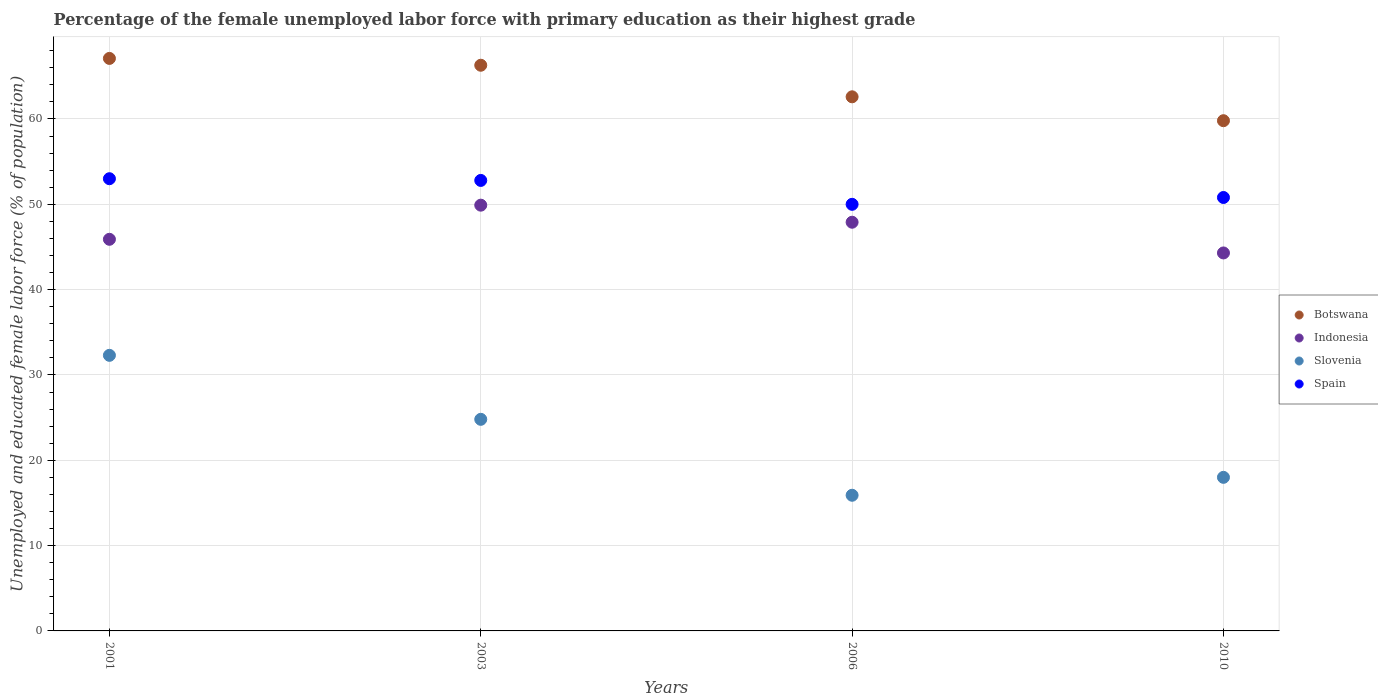Is the number of dotlines equal to the number of legend labels?
Offer a terse response. Yes. What is the percentage of the unemployed female labor force with primary education in Botswana in 2001?
Ensure brevity in your answer.  67.1. Across all years, what is the maximum percentage of the unemployed female labor force with primary education in Slovenia?
Offer a terse response. 32.3. Across all years, what is the minimum percentage of the unemployed female labor force with primary education in Botswana?
Offer a terse response. 59.8. What is the total percentage of the unemployed female labor force with primary education in Slovenia in the graph?
Your response must be concise. 91. What is the difference between the percentage of the unemployed female labor force with primary education in Botswana in 2003 and that in 2010?
Your answer should be compact. 6.5. What is the average percentage of the unemployed female labor force with primary education in Botswana per year?
Your response must be concise. 63.95. In the year 2003, what is the difference between the percentage of the unemployed female labor force with primary education in Spain and percentage of the unemployed female labor force with primary education in Botswana?
Offer a terse response. -13.5. In how many years, is the percentage of the unemployed female labor force with primary education in Spain greater than 50 %?
Offer a very short reply. 3. What is the ratio of the percentage of the unemployed female labor force with primary education in Slovenia in 2006 to that in 2010?
Offer a very short reply. 0.88. Is the percentage of the unemployed female labor force with primary education in Indonesia in 2006 less than that in 2010?
Offer a very short reply. No. Is the difference between the percentage of the unemployed female labor force with primary education in Spain in 2003 and 2010 greater than the difference between the percentage of the unemployed female labor force with primary education in Botswana in 2003 and 2010?
Give a very brief answer. No. What is the difference between the highest and the second highest percentage of the unemployed female labor force with primary education in Slovenia?
Your answer should be very brief. 7.5. What is the difference between the highest and the lowest percentage of the unemployed female labor force with primary education in Indonesia?
Your answer should be compact. 5.6. In how many years, is the percentage of the unemployed female labor force with primary education in Botswana greater than the average percentage of the unemployed female labor force with primary education in Botswana taken over all years?
Make the answer very short. 2. How many dotlines are there?
Offer a terse response. 4. How many years are there in the graph?
Your response must be concise. 4. What is the difference between two consecutive major ticks on the Y-axis?
Your answer should be compact. 10. Are the values on the major ticks of Y-axis written in scientific E-notation?
Provide a succinct answer. No. Where does the legend appear in the graph?
Your response must be concise. Center right. How many legend labels are there?
Ensure brevity in your answer.  4. What is the title of the graph?
Provide a succinct answer. Percentage of the female unemployed labor force with primary education as their highest grade. Does "Cyprus" appear as one of the legend labels in the graph?
Provide a succinct answer. No. What is the label or title of the X-axis?
Make the answer very short. Years. What is the label or title of the Y-axis?
Ensure brevity in your answer.  Unemployed and educated female labor force (% of population). What is the Unemployed and educated female labor force (% of population) of Botswana in 2001?
Ensure brevity in your answer.  67.1. What is the Unemployed and educated female labor force (% of population) in Indonesia in 2001?
Provide a succinct answer. 45.9. What is the Unemployed and educated female labor force (% of population) in Slovenia in 2001?
Give a very brief answer. 32.3. What is the Unemployed and educated female labor force (% of population) of Spain in 2001?
Make the answer very short. 53. What is the Unemployed and educated female labor force (% of population) of Botswana in 2003?
Provide a short and direct response. 66.3. What is the Unemployed and educated female labor force (% of population) in Indonesia in 2003?
Ensure brevity in your answer.  49.9. What is the Unemployed and educated female labor force (% of population) of Slovenia in 2003?
Your answer should be very brief. 24.8. What is the Unemployed and educated female labor force (% of population) in Spain in 2003?
Make the answer very short. 52.8. What is the Unemployed and educated female labor force (% of population) of Botswana in 2006?
Offer a terse response. 62.6. What is the Unemployed and educated female labor force (% of population) in Indonesia in 2006?
Your answer should be compact. 47.9. What is the Unemployed and educated female labor force (% of population) of Slovenia in 2006?
Provide a succinct answer. 15.9. What is the Unemployed and educated female labor force (% of population) in Botswana in 2010?
Offer a very short reply. 59.8. What is the Unemployed and educated female labor force (% of population) of Indonesia in 2010?
Your answer should be compact. 44.3. What is the Unemployed and educated female labor force (% of population) in Spain in 2010?
Provide a short and direct response. 50.8. Across all years, what is the maximum Unemployed and educated female labor force (% of population) in Botswana?
Keep it short and to the point. 67.1. Across all years, what is the maximum Unemployed and educated female labor force (% of population) of Indonesia?
Ensure brevity in your answer.  49.9. Across all years, what is the maximum Unemployed and educated female labor force (% of population) of Slovenia?
Provide a succinct answer. 32.3. Across all years, what is the maximum Unemployed and educated female labor force (% of population) of Spain?
Keep it short and to the point. 53. Across all years, what is the minimum Unemployed and educated female labor force (% of population) in Botswana?
Your answer should be very brief. 59.8. Across all years, what is the minimum Unemployed and educated female labor force (% of population) of Indonesia?
Provide a short and direct response. 44.3. Across all years, what is the minimum Unemployed and educated female labor force (% of population) of Slovenia?
Your answer should be very brief. 15.9. Across all years, what is the minimum Unemployed and educated female labor force (% of population) in Spain?
Ensure brevity in your answer.  50. What is the total Unemployed and educated female labor force (% of population) in Botswana in the graph?
Offer a terse response. 255.8. What is the total Unemployed and educated female labor force (% of population) of Indonesia in the graph?
Ensure brevity in your answer.  188. What is the total Unemployed and educated female labor force (% of population) in Slovenia in the graph?
Offer a terse response. 91. What is the total Unemployed and educated female labor force (% of population) of Spain in the graph?
Provide a short and direct response. 206.6. What is the difference between the Unemployed and educated female labor force (% of population) of Botswana in 2001 and that in 2003?
Give a very brief answer. 0.8. What is the difference between the Unemployed and educated female labor force (% of population) in Slovenia in 2001 and that in 2003?
Your answer should be very brief. 7.5. What is the difference between the Unemployed and educated female labor force (% of population) of Spain in 2001 and that in 2003?
Offer a terse response. 0.2. What is the difference between the Unemployed and educated female labor force (% of population) of Botswana in 2001 and that in 2006?
Offer a very short reply. 4.5. What is the difference between the Unemployed and educated female labor force (% of population) in Indonesia in 2001 and that in 2006?
Provide a succinct answer. -2. What is the difference between the Unemployed and educated female labor force (% of population) in Slovenia in 2001 and that in 2010?
Your response must be concise. 14.3. What is the difference between the Unemployed and educated female labor force (% of population) of Spain in 2001 and that in 2010?
Keep it short and to the point. 2.2. What is the difference between the Unemployed and educated female labor force (% of population) of Indonesia in 2003 and that in 2006?
Ensure brevity in your answer.  2. What is the difference between the Unemployed and educated female labor force (% of population) of Slovenia in 2003 and that in 2006?
Your answer should be very brief. 8.9. What is the difference between the Unemployed and educated female labor force (% of population) in Indonesia in 2003 and that in 2010?
Your answer should be very brief. 5.6. What is the difference between the Unemployed and educated female labor force (% of population) of Slovenia in 2003 and that in 2010?
Provide a succinct answer. 6.8. What is the difference between the Unemployed and educated female labor force (% of population) of Botswana in 2006 and that in 2010?
Ensure brevity in your answer.  2.8. What is the difference between the Unemployed and educated female labor force (% of population) in Slovenia in 2006 and that in 2010?
Offer a terse response. -2.1. What is the difference between the Unemployed and educated female labor force (% of population) in Spain in 2006 and that in 2010?
Your response must be concise. -0.8. What is the difference between the Unemployed and educated female labor force (% of population) of Botswana in 2001 and the Unemployed and educated female labor force (% of population) of Indonesia in 2003?
Ensure brevity in your answer.  17.2. What is the difference between the Unemployed and educated female labor force (% of population) in Botswana in 2001 and the Unemployed and educated female labor force (% of population) in Slovenia in 2003?
Provide a short and direct response. 42.3. What is the difference between the Unemployed and educated female labor force (% of population) of Indonesia in 2001 and the Unemployed and educated female labor force (% of population) of Slovenia in 2003?
Offer a terse response. 21.1. What is the difference between the Unemployed and educated female labor force (% of population) in Indonesia in 2001 and the Unemployed and educated female labor force (% of population) in Spain in 2003?
Your answer should be compact. -6.9. What is the difference between the Unemployed and educated female labor force (% of population) of Slovenia in 2001 and the Unemployed and educated female labor force (% of population) of Spain in 2003?
Your response must be concise. -20.5. What is the difference between the Unemployed and educated female labor force (% of population) of Botswana in 2001 and the Unemployed and educated female labor force (% of population) of Slovenia in 2006?
Provide a short and direct response. 51.2. What is the difference between the Unemployed and educated female labor force (% of population) of Botswana in 2001 and the Unemployed and educated female labor force (% of population) of Spain in 2006?
Give a very brief answer. 17.1. What is the difference between the Unemployed and educated female labor force (% of population) of Indonesia in 2001 and the Unemployed and educated female labor force (% of population) of Spain in 2006?
Offer a very short reply. -4.1. What is the difference between the Unemployed and educated female labor force (% of population) of Slovenia in 2001 and the Unemployed and educated female labor force (% of population) of Spain in 2006?
Ensure brevity in your answer.  -17.7. What is the difference between the Unemployed and educated female labor force (% of population) of Botswana in 2001 and the Unemployed and educated female labor force (% of population) of Indonesia in 2010?
Give a very brief answer. 22.8. What is the difference between the Unemployed and educated female labor force (% of population) in Botswana in 2001 and the Unemployed and educated female labor force (% of population) in Slovenia in 2010?
Make the answer very short. 49.1. What is the difference between the Unemployed and educated female labor force (% of population) in Indonesia in 2001 and the Unemployed and educated female labor force (% of population) in Slovenia in 2010?
Offer a very short reply. 27.9. What is the difference between the Unemployed and educated female labor force (% of population) of Slovenia in 2001 and the Unemployed and educated female labor force (% of population) of Spain in 2010?
Give a very brief answer. -18.5. What is the difference between the Unemployed and educated female labor force (% of population) in Botswana in 2003 and the Unemployed and educated female labor force (% of population) in Slovenia in 2006?
Give a very brief answer. 50.4. What is the difference between the Unemployed and educated female labor force (% of population) of Botswana in 2003 and the Unemployed and educated female labor force (% of population) of Spain in 2006?
Your response must be concise. 16.3. What is the difference between the Unemployed and educated female labor force (% of population) in Indonesia in 2003 and the Unemployed and educated female labor force (% of population) in Slovenia in 2006?
Offer a very short reply. 34. What is the difference between the Unemployed and educated female labor force (% of population) of Indonesia in 2003 and the Unemployed and educated female labor force (% of population) of Spain in 2006?
Ensure brevity in your answer.  -0.1. What is the difference between the Unemployed and educated female labor force (% of population) in Slovenia in 2003 and the Unemployed and educated female labor force (% of population) in Spain in 2006?
Your response must be concise. -25.2. What is the difference between the Unemployed and educated female labor force (% of population) of Botswana in 2003 and the Unemployed and educated female labor force (% of population) of Slovenia in 2010?
Your response must be concise. 48.3. What is the difference between the Unemployed and educated female labor force (% of population) of Indonesia in 2003 and the Unemployed and educated female labor force (% of population) of Slovenia in 2010?
Ensure brevity in your answer.  31.9. What is the difference between the Unemployed and educated female labor force (% of population) in Indonesia in 2003 and the Unemployed and educated female labor force (% of population) in Spain in 2010?
Make the answer very short. -0.9. What is the difference between the Unemployed and educated female labor force (% of population) of Botswana in 2006 and the Unemployed and educated female labor force (% of population) of Indonesia in 2010?
Provide a succinct answer. 18.3. What is the difference between the Unemployed and educated female labor force (% of population) in Botswana in 2006 and the Unemployed and educated female labor force (% of population) in Slovenia in 2010?
Make the answer very short. 44.6. What is the difference between the Unemployed and educated female labor force (% of population) in Botswana in 2006 and the Unemployed and educated female labor force (% of population) in Spain in 2010?
Provide a succinct answer. 11.8. What is the difference between the Unemployed and educated female labor force (% of population) in Indonesia in 2006 and the Unemployed and educated female labor force (% of population) in Slovenia in 2010?
Your answer should be compact. 29.9. What is the difference between the Unemployed and educated female labor force (% of population) in Slovenia in 2006 and the Unemployed and educated female labor force (% of population) in Spain in 2010?
Give a very brief answer. -34.9. What is the average Unemployed and educated female labor force (% of population) of Botswana per year?
Offer a terse response. 63.95. What is the average Unemployed and educated female labor force (% of population) of Indonesia per year?
Your response must be concise. 47. What is the average Unemployed and educated female labor force (% of population) in Slovenia per year?
Offer a very short reply. 22.75. What is the average Unemployed and educated female labor force (% of population) in Spain per year?
Your answer should be compact. 51.65. In the year 2001, what is the difference between the Unemployed and educated female labor force (% of population) of Botswana and Unemployed and educated female labor force (% of population) of Indonesia?
Ensure brevity in your answer.  21.2. In the year 2001, what is the difference between the Unemployed and educated female labor force (% of population) in Botswana and Unemployed and educated female labor force (% of population) in Slovenia?
Provide a succinct answer. 34.8. In the year 2001, what is the difference between the Unemployed and educated female labor force (% of population) of Indonesia and Unemployed and educated female labor force (% of population) of Slovenia?
Make the answer very short. 13.6. In the year 2001, what is the difference between the Unemployed and educated female labor force (% of population) of Slovenia and Unemployed and educated female labor force (% of population) of Spain?
Make the answer very short. -20.7. In the year 2003, what is the difference between the Unemployed and educated female labor force (% of population) in Botswana and Unemployed and educated female labor force (% of population) in Indonesia?
Ensure brevity in your answer.  16.4. In the year 2003, what is the difference between the Unemployed and educated female labor force (% of population) of Botswana and Unemployed and educated female labor force (% of population) of Slovenia?
Offer a terse response. 41.5. In the year 2003, what is the difference between the Unemployed and educated female labor force (% of population) of Botswana and Unemployed and educated female labor force (% of population) of Spain?
Make the answer very short. 13.5. In the year 2003, what is the difference between the Unemployed and educated female labor force (% of population) of Indonesia and Unemployed and educated female labor force (% of population) of Slovenia?
Your answer should be compact. 25.1. In the year 2003, what is the difference between the Unemployed and educated female labor force (% of population) in Indonesia and Unemployed and educated female labor force (% of population) in Spain?
Give a very brief answer. -2.9. In the year 2006, what is the difference between the Unemployed and educated female labor force (% of population) of Botswana and Unemployed and educated female labor force (% of population) of Indonesia?
Provide a succinct answer. 14.7. In the year 2006, what is the difference between the Unemployed and educated female labor force (% of population) in Botswana and Unemployed and educated female labor force (% of population) in Slovenia?
Your answer should be compact. 46.7. In the year 2006, what is the difference between the Unemployed and educated female labor force (% of population) in Botswana and Unemployed and educated female labor force (% of population) in Spain?
Ensure brevity in your answer.  12.6. In the year 2006, what is the difference between the Unemployed and educated female labor force (% of population) of Indonesia and Unemployed and educated female labor force (% of population) of Spain?
Your response must be concise. -2.1. In the year 2006, what is the difference between the Unemployed and educated female labor force (% of population) in Slovenia and Unemployed and educated female labor force (% of population) in Spain?
Keep it short and to the point. -34.1. In the year 2010, what is the difference between the Unemployed and educated female labor force (% of population) in Botswana and Unemployed and educated female labor force (% of population) in Slovenia?
Your response must be concise. 41.8. In the year 2010, what is the difference between the Unemployed and educated female labor force (% of population) of Indonesia and Unemployed and educated female labor force (% of population) of Slovenia?
Your answer should be compact. 26.3. In the year 2010, what is the difference between the Unemployed and educated female labor force (% of population) in Indonesia and Unemployed and educated female labor force (% of population) in Spain?
Provide a short and direct response. -6.5. In the year 2010, what is the difference between the Unemployed and educated female labor force (% of population) of Slovenia and Unemployed and educated female labor force (% of population) of Spain?
Keep it short and to the point. -32.8. What is the ratio of the Unemployed and educated female labor force (% of population) of Botswana in 2001 to that in 2003?
Provide a succinct answer. 1.01. What is the ratio of the Unemployed and educated female labor force (% of population) of Indonesia in 2001 to that in 2003?
Offer a very short reply. 0.92. What is the ratio of the Unemployed and educated female labor force (% of population) in Slovenia in 2001 to that in 2003?
Ensure brevity in your answer.  1.3. What is the ratio of the Unemployed and educated female labor force (% of population) of Spain in 2001 to that in 2003?
Give a very brief answer. 1. What is the ratio of the Unemployed and educated female labor force (% of population) in Botswana in 2001 to that in 2006?
Make the answer very short. 1.07. What is the ratio of the Unemployed and educated female labor force (% of population) of Indonesia in 2001 to that in 2006?
Keep it short and to the point. 0.96. What is the ratio of the Unemployed and educated female labor force (% of population) of Slovenia in 2001 to that in 2006?
Your answer should be very brief. 2.03. What is the ratio of the Unemployed and educated female labor force (% of population) of Spain in 2001 to that in 2006?
Make the answer very short. 1.06. What is the ratio of the Unemployed and educated female labor force (% of population) of Botswana in 2001 to that in 2010?
Offer a terse response. 1.12. What is the ratio of the Unemployed and educated female labor force (% of population) in Indonesia in 2001 to that in 2010?
Your answer should be compact. 1.04. What is the ratio of the Unemployed and educated female labor force (% of population) in Slovenia in 2001 to that in 2010?
Provide a short and direct response. 1.79. What is the ratio of the Unemployed and educated female labor force (% of population) in Spain in 2001 to that in 2010?
Keep it short and to the point. 1.04. What is the ratio of the Unemployed and educated female labor force (% of population) in Botswana in 2003 to that in 2006?
Your answer should be very brief. 1.06. What is the ratio of the Unemployed and educated female labor force (% of population) in Indonesia in 2003 to that in 2006?
Provide a succinct answer. 1.04. What is the ratio of the Unemployed and educated female labor force (% of population) in Slovenia in 2003 to that in 2006?
Ensure brevity in your answer.  1.56. What is the ratio of the Unemployed and educated female labor force (% of population) in Spain in 2003 to that in 2006?
Your answer should be very brief. 1.06. What is the ratio of the Unemployed and educated female labor force (% of population) in Botswana in 2003 to that in 2010?
Offer a terse response. 1.11. What is the ratio of the Unemployed and educated female labor force (% of population) of Indonesia in 2003 to that in 2010?
Your answer should be compact. 1.13. What is the ratio of the Unemployed and educated female labor force (% of population) in Slovenia in 2003 to that in 2010?
Make the answer very short. 1.38. What is the ratio of the Unemployed and educated female labor force (% of population) of Spain in 2003 to that in 2010?
Offer a very short reply. 1.04. What is the ratio of the Unemployed and educated female labor force (% of population) of Botswana in 2006 to that in 2010?
Give a very brief answer. 1.05. What is the ratio of the Unemployed and educated female labor force (% of population) of Indonesia in 2006 to that in 2010?
Ensure brevity in your answer.  1.08. What is the ratio of the Unemployed and educated female labor force (% of population) of Slovenia in 2006 to that in 2010?
Provide a short and direct response. 0.88. What is the ratio of the Unemployed and educated female labor force (% of population) of Spain in 2006 to that in 2010?
Offer a terse response. 0.98. What is the difference between the highest and the second highest Unemployed and educated female labor force (% of population) in Indonesia?
Give a very brief answer. 2. What is the difference between the highest and the second highest Unemployed and educated female labor force (% of population) of Slovenia?
Your answer should be compact. 7.5. What is the difference between the highest and the second highest Unemployed and educated female labor force (% of population) of Spain?
Offer a terse response. 0.2. What is the difference between the highest and the lowest Unemployed and educated female labor force (% of population) of Indonesia?
Make the answer very short. 5.6. What is the difference between the highest and the lowest Unemployed and educated female labor force (% of population) of Slovenia?
Give a very brief answer. 16.4. 